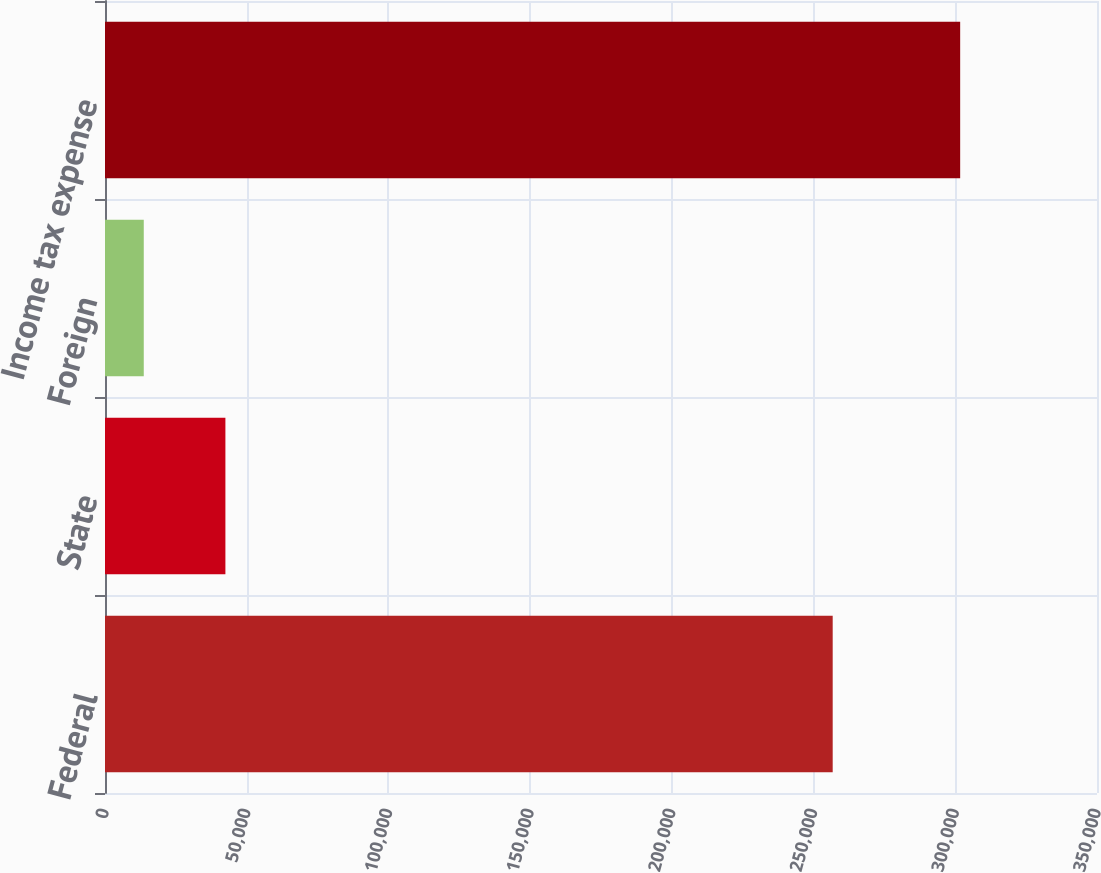Convert chart. <chart><loc_0><loc_0><loc_500><loc_500><bar_chart><fcel>Federal<fcel>State<fcel>Foreign<fcel>Income tax expense<nl><fcel>256748<fcel>42481.5<fcel>13677<fcel>301722<nl></chart> 